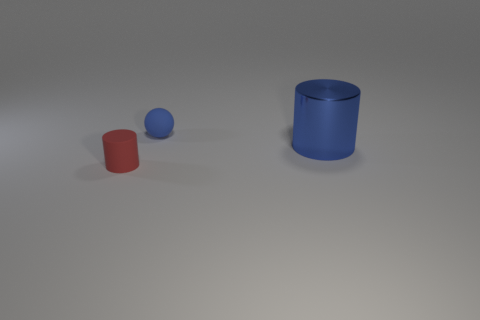Is there any other thing that has the same size as the blue cylinder?
Provide a short and direct response. No. How many small spheres are behind the tiny object behind the tiny red matte object?
Your answer should be very brief. 0. Are there fewer red cylinders that are behind the small blue rubber thing than large cyan cubes?
Your answer should be compact. No. Is there a rubber object in front of the blue thing that is on the left side of the large object that is to the right of the small red matte cylinder?
Your answer should be compact. Yes. Are the tiny red cylinder and the object that is behind the large thing made of the same material?
Provide a short and direct response. Yes. What is the color of the tiny thing that is behind the cylinder that is in front of the big blue cylinder?
Your answer should be compact. Blue. Are there any rubber spheres that have the same color as the large metallic thing?
Your answer should be very brief. Yes. What size is the cylinder that is right of the tiny object that is to the left of the small object that is behind the tiny red thing?
Your response must be concise. Large. There is a shiny object; does it have the same shape as the rubber thing left of the blue matte thing?
Offer a terse response. Yes. How many other things are there of the same size as the shiny object?
Your response must be concise. 0. 